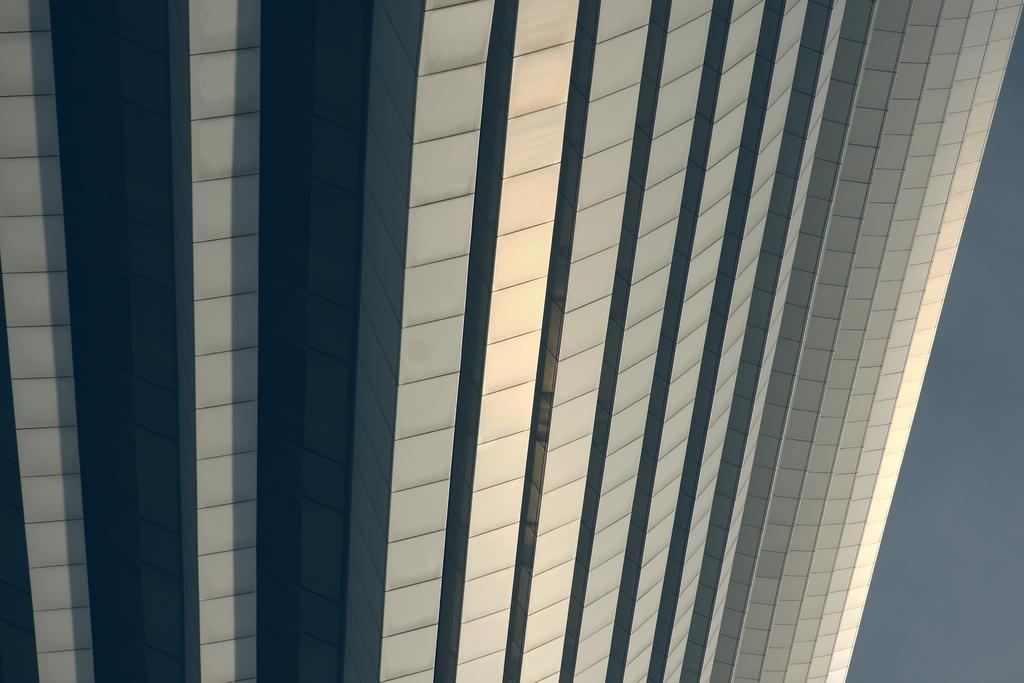What type of structure is in the picture? There is a tall building in the picture. What color is the sky in the picture? The sky is blue in the picture. How many inches tall is the health in the picture? There is no mention of health or any measurement in the picture, so it cannot be determined. 